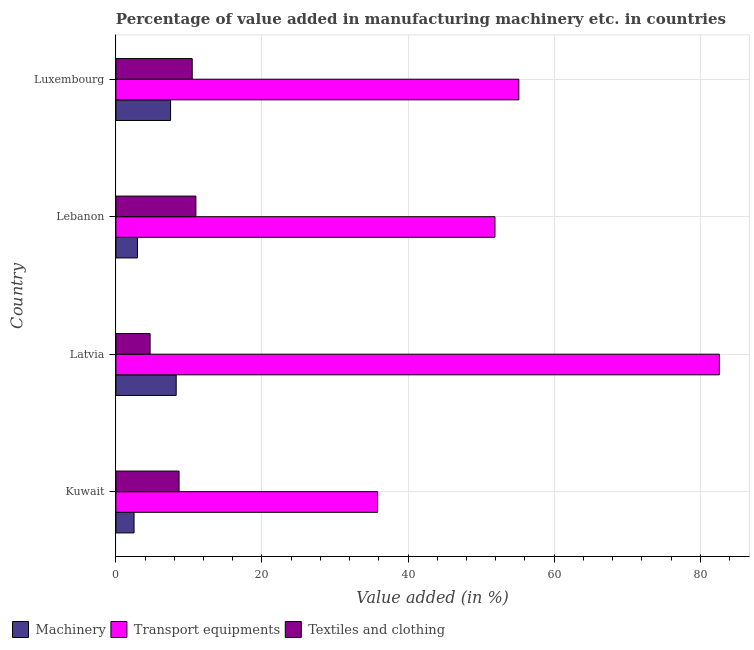How many different coloured bars are there?
Give a very brief answer. 3. How many groups of bars are there?
Give a very brief answer. 4. Are the number of bars per tick equal to the number of legend labels?
Your response must be concise. Yes. How many bars are there on the 3rd tick from the top?
Your answer should be very brief. 3. What is the label of the 2nd group of bars from the top?
Give a very brief answer. Lebanon. In how many cases, is the number of bars for a given country not equal to the number of legend labels?
Offer a very short reply. 0. What is the value added in manufacturing textile and clothing in Kuwait?
Keep it short and to the point. 8.65. Across all countries, what is the maximum value added in manufacturing textile and clothing?
Ensure brevity in your answer.  10.95. Across all countries, what is the minimum value added in manufacturing transport equipments?
Ensure brevity in your answer.  35.83. In which country was the value added in manufacturing transport equipments maximum?
Ensure brevity in your answer.  Latvia. In which country was the value added in manufacturing transport equipments minimum?
Provide a succinct answer. Kuwait. What is the total value added in manufacturing transport equipments in the graph?
Your answer should be very brief. 225.48. What is the difference between the value added in manufacturing textile and clothing in Latvia and that in Luxembourg?
Ensure brevity in your answer.  -5.77. What is the difference between the value added in manufacturing machinery in Luxembourg and the value added in manufacturing transport equipments in Lebanon?
Your answer should be compact. -44.41. What is the average value added in manufacturing transport equipments per country?
Keep it short and to the point. 56.37. What is the difference between the value added in manufacturing transport equipments and value added in manufacturing machinery in Lebanon?
Offer a very short reply. 48.94. What is the ratio of the value added in manufacturing transport equipments in Latvia to that in Luxembourg?
Ensure brevity in your answer.  1.5. Is the difference between the value added in manufacturing transport equipments in Kuwait and Latvia greater than the difference between the value added in manufacturing machinery in Kuwait and Latvia?
Your answer should be compact. No. What is the difference between the highest and the second highest value added in manufacturing transport equipments?
Your response must be concise. 27.45. What is the difference between the highest and the lowest value added in manufacturing textile and clothing?
Your answer should be very brief. 6.27. In how many countries, is the value added in manufacturing textile and clothing greater than the average value added in manufacturing textile and clothing taken over all countries?
Offer a very short reply. 2. Is the sum of the value added in manufacturing textile and clothing in Latvia and Luxembourg greater than the maximum value added in manufacturing transport equipments across all countries?
Your answer should be compact. No. What does the 1st bar from the top in Kuwait represents?
Your answer should be very brief. Textiles and clothing. What does the 1st bar from the bottom in Latvia represents?
Keep it short and to the point. Machinery. Is it the case that in every country, the sum of the value added in manufacturing machinery and value added in manufacturing transport equipments is greater than the value added in manufacturing textile and clothing?
Provide a short and direct response. Yes. What is the difference between two consecutive major ticks on the X-axis?
Offer a terse response. 20. Are the values on the major ticks of X-axis written in scientific E-notation?
Make the answer very short. No. Where does the legend appear in the graph?
Ensure brevity in your answer.  Bottom left. How many legend labels are there?
Offer a very short reply. 3. How are the legend labels stacked?
Your answer should be very brief. Horizontal. What is the title of the graph?
Give a very brief answer. Percentage of value added in manufacturing machinery etc. in countries. Does "Textiles and clothing" appear as one of the legend labels in the graph?
Your answer should be very brief. Yes. What is the label or title of the X-axis?
Your response must be concise. Value added (in %). What is the Value added (in %) in Machinery in Kuwait?
Provide a short and direct response. 2.49. What is the Value added (in %) of Transport equipments in Kuwait?
Your answer should be compact. 35.83. What is the Value added (in %) in Textiles and clothing in Kuwait?
Offer a very short reply. 8.65. What is the Value added (in %) of Machinery in Latvia?
Offer a terse response. 8.26. What is the Value added (in %) in Transport equipments in Latvia?
Provide a succinct answer. 82.6. What is the Value added (in %) of Textiles and clothing in Latvia?
Provide a succinct answer. 4.68. What is the Value added (in %) of Machinery in Lebanon?
Provide a succinct answer. 2.95. What is the Value added (in %) in Transport equipments in Lebanon?
Provide a short and direct response. 51.89. What is the Value added (in %) in Textiles and clothing in Lebanon?
Provide a succinct answer. 10.95. What is the Value added (in %) in Machinery in Luxembourg?
Give a very brief answer. 7.49. What is the Value added (in %) in Transport equipments in Luxembourg?
Offer a terse response. 55.16. What is the Value added (in %) of Textiles and clothing in Luxembourg?
Offer a very short reply. 10.45. Across all countries, what is the maximum Value added (in %) of Machinery?
Your response must be concise. 8.26. Across all countries, what is the maximum Value added (in %) of Transport equipments?
Keep it short and to the point. 82.6. Across all countries, what is the maximum Value added (in %) in Textiles and clothing?
Your response must be concise. 10.95. Across all countries, what is the minimum Value added (in %) in Machinery?
Ensure brevity in your answer.  2.49. Across all countries, what is the minimum Value added (in %) of Transport equipments?
Your response must be concise. 35.83. Across all countries, what is the minimum Value added (in %) in Textiles and clothing?
Make the answer very short. 4.68. What is the total Value added (in %) in Machinery in the graph?
Keep it short and to the point. 21.18. What is the total Value added (in %) in Transport equipments in the graph?
Offer a terse response. 225.48. What is the total Value added (in %) of Textiles and clothing in the graph?
Ensure brevity in your answer.  34.73. What is the difference between the Value added (in %) of Machinery in Kuwait and that in Latvia?
Give a very brief answer. -5.77. What is the difference between the Value added (in %) in Transport equipments in Kuwait and that in Latvia?
Provide a succinct answer. -46.78. What is the difference between the Value added (in %) in Textiles and clothing in Kuwait and that in Latvia?
Offer a terse response. 3.96. What is the difference between the Value added (in %) of Machinery in Kuwait and that in Lebanon?
Make the answer very short. -0.47. What is the difference between the Value added (in %) of Transport equipments in Kuwait and that in Lebanon?
Offer a very short reply. -16.07. What is the difference between the Value added (in %) of Textiles and clothing in Kuwait and that in Lebanon?
Your response must be concise. -2.3. What is the difference between the Value added (in %) of Machinery in Kuwait and that in Luxembourg?
Ensure brevity in your answer.  -5. What is the difference between the Value added (in %) of Transport equipments in Kuwait and that in Luxembourg?
Keep it short and to the point. -19.33. What is the difference between the Value added (in %) of Textiles and clothing in Kuwait and that in Luxembourg?
Offer a very short reply. -1.8. What is the difference between the Value added (in %) in Machinery in Latvia and that in Lebanon?
Give a very brief answer. 5.3. What is the difference between the Value added (in %) of Transport equipments in Latvia and that in Lebanon?
Provide a short and direct response. 30.71. What is the difference between the Value added (in %) of Textiles and clothing in Latvia and that in Lebanon?
Provide a succinct answer. -6.27. What is the difference between the Value added (in %) of Machinery in Latvia and that in Luxembourg?
Your response must be concise. 0.77. What is the difference between the Value added (in %) of Transport equipments in Latvia and that in Luxembourg?
Your answer should be compact. 27.45. What is the difference between the Value added (in %) in Textiles and clothing in Latvia and that in Luxembourg?
Offer a very short reply. -5.77. What is the difference between the Value added (in %) in Machinery in Lebanon and that in Luxembourg?
Make the answer very short. -4.53. What is the difference between the Value added (in %) in Transport equipments in Lebanon and that in Luxembourg?
Make the answer very short. -3.27. What is the difference between the Value added (in %) in Textiles and clothing in Lebanon and that in Luxembourg?
Provide a short and direct response. 0.5. What is the difference between the Value added (in %) in Machinery in Kuwait and the Value added (in %) in Transport equipments in Latvia?
Provide a succinct answer. -80.12. What is the difference between the Value added (in %) in Machinery in Kuwait and the Value added (in %) in Textiles and clothing in Latvia?
Provide a short and direct response. -2.2. What is the difference between the Value added (in %) of Transport equipments in Kuwait and the Value added (in %) of Textiles and clothing in Latvia?
Keep it short and to the point. 31.14. What is the difference between the Value added (in %) in Machinery in Kuwait and the Value added (in %) in Transport equipments in Lebanon?
Keep it short and to the point. -49.41. What is the difference between the Value added (in %) of Machinery in Kuwait and the Value added (in %) of Textiles and clothing in Lebanon?
Your answer should be compact. -8.46. What is the difference between the Value added (in %) of Transport equipments in Kuwait and the Value added (in %) of Textiles and clothing in Lebanon?
Give a very brief answer. 24.88. What is the difference between the Value added (in %) of Machinery in Kuwait and the Value added (in %) of Transport equipments in Luxembourg?
Make the answer very short. -52.67. What is the difference between the Value added (in %) in Machinery in Kuwait and the Value added (in %) in Textiles and clothing in Luxembourg?
Offer a terse response. -7.96. What is the difference between the Value added (in %) in Transport equipments in Kuwait and the Value added (in %) in Textiles and clothing in Luxembourg?
Make the answer very short. 25.38. What is the difference between the Value added (in %) in Machinery in Latvia and the Value added (in %) in Transport equipments in Lebanon?
Keep it short and to the point. -43.64. What is the difference between the Value added (in %) in Machinery in Latvia and the Value added (in %) in Textiles and clothing in Lebanon?
Offer a very short reply. -2.69. What is the difference between the Value added (in %) in Transport equipments in Latvia and the Value added (in %) in Textiles and clothing in Lebanon?
Offer a very short reply. 71.65. What is the difference between the Value added (in %) in Machinery in Latvia and the Value added (in %) in Transport equipments in Luxembourg?
Give a very brief answer. -46.9. What is the difference between the Value added (in %) of Machinery in Latvia and the Value added (in %) of Textiles and clothing in Luxembourg?
Give a very brief answer. -2.19. What is the difference between the Value added (in %) in Transport equipments in Latvia and the Value added (in %) in Textiles and clothing in Luxembourg?
Your response must be concise. 72.15. What is the difference between the Value added (in %) in Machinery in Lebanon and the Value added (in %) in Transport equipments in Luxembourg?
Provide a short and direct response. -52.2. What is the difference between the Value added (in %) in Machinery in Lebanon and the Value added (in %) in Textiles and clothing in Luxembourg?
Your answer should be compact. -7.5. What is the difference between the Value added (in %) of Transport equipments in Lebanon and the Value added (in %) of Textiles and clothing in Luxembourg?
Give a very brief answer. 41.44. What is the average Value added (in %) of Machinery per country?
Your answer should be compact. 5.3. What is the average Value added (in %) in Transport equipments per country?
Provide a short and direct response. 56.37. What is the average Value added (in %) in Textiles and clothing per country?
Your response must be concise. 8.68. What is the difference between the Value added (in %) of Machinery and Value added (in %) of Transport equipments in Kuwait?
Ensure brevity in your answer.  -33.34. What is the difference between the Value added (in %) in Machinery and Value added (in %) in Textiles and clothing in Kuwait?
Provide a succinct answer. -6.16. What is the difference between the Value added (in %) of Transport equipments and Value added (in %) of Textiles and clothing in Kuwait?
Provide a short and direct response. 27.18. What is the difference between the Value added (in %) in Machinery and Value added (in %) in Transport equipments in Latvia?
Give a very brief answer. -74.35. What is the difference between the Value added (in %) of Machinery and Value added (in %) of Textiles and clothing in Latvia?
Your response must be concise. 3.57. What is the difference between the Value added (in %) of Transport equipments and Value added (in %) of Textiles and clothing in Latvia?
Provide a succinct answer. 77.92. What is the difference between the Value added (in %) of Machinery and Value added (in %) of Transport equipments in Lebanon?
Make the answer very short. -48.94. What is the difference between the Value added (in %) in Machinery and Value added (in %) in Textiles and clothing in Lebanon?
Offer a terse response. -8. What is the difference between the Value added (in %) of Transport equipments and Value added (in %) of Textiles and clothing in Lebanon?
Ensure brevity in your answer.  40.94. What is the difference between the Value added (in %) in Machinery and Value added (in %) in Transport equipments in Luxembourg?
Provide a short and direct response. -47.67. What is the difference between the Value added (in %) of Machinery and Value added (in %) of Textiles and clothing in Luxembourg?
Provide a succinct answer. -2.96. What is the difference between the Value added (in %) in Transport equipments and Value added (in %) in Textiles and clothing in Luxembourg?
Give a very brief answer. 44.71. What is the ratio of the Value added (in %) in Machinery in Kuwait to that in Latvia?
Offer a terse response. 0.3. What is the ratio of the Value added (in %) of Transport equipments in Kuwait to that in Latvia?
Provide a succinct answer. 0.43. What is the ratio of the Value added (in %) in Textiles and clothing in Kuwait to that in Latvia?
Your answer should be very brief. 1.85. What is the ratio of the Value added (in %) of Machinery in Kuwait to that in Lebanon?
Your answer should be very brief. 0.84. What is the ratio of the Value added (in %) of Transport equipments in Kuwait to that in Lebanon?
Offer a terse response. 0.69. What is the ratio of the Value added (in %) of Textiles and clothing in Kuwait to that in Lebanon?
Ensure brevity in your answer.  0.79. What is the ratio of the Value added (in %) in Machinery in Kuwait to that in Luxembourg?
Ensure brevity in your answer.  0.33. What is the ratio of the Value added (in %) in Transport equipments in Kuwait to that in Luxembourg?
Your response must be concise. 0.65. What is the ratio of the Value added (in %) of Textiles and clothing in Kuwait to that in Luxembourg?
Ensure brevity in your answer.  0.83. What is the ratio of the Value added (in %) in Machinery in Latvia to that in Lebanon?
Ensure brevity in your answer.  2.8. What is the ratio of the Value added (in %) in Transport equipments in Latvia to that in Lebanon?
Your answer should be compact. 1.59. What is the ratio of the Value added (in %) in Textiles and clothing in Latvia to that in Lebanon?
Your answer should be compact. 0.43. What is the ratio of the Value added (in %) in Machinery in Latvia to that in Luxembourg?
Give a very brief answer. 1.1. What is the ratio of the Value added (in %) in Transport equipments in Latvia to that in Luxembourg?
Provide a succinct answer. 1.5. What is the ratio of the Value added (in %) in Textiles and clothing in Latvia to that in Luxembourg?
Ensure brevity in your answer.  0.45. What is the ratio of the Value added (in %) of Machinery in Lebanon to that in Luxembourg?
Give a very brief answer. 0.39. What is the ratio of the Value added (in %) of Transport equipments in Lebanon to that in Luxembourg?
Provide a succinct answer. 0.94. What is the ratio of the Value added (in %) in Textiles and clothing in Lebanon to that in Luxembourg?
Your answer should be very brief. 1.05. What is the difference between the highest and the second highest Value added (in %) in Machinery?
Keep it short and to the point. 0.77. What is the difference between the highest and the second highest Value added (in %) of Transport equipments?
Provide a succinct answer. 27.45. What is the difference between the highest and the second highest Value added (in %) of Textiles and clothing?
Give a very brief answer. 0.5. What is the difference between the highest and the lowest Value added (in %) in Machinery?
Provide a succinct answer. 5.77. What is the difference between the highest and the lowest Value added (in %) of Transport equipments?
Provide a short and direct response. 46.78. What is the difference between the highest and the lowest Value added (in %) of Textiles and clothing?
Ensure brevity in your answer.  6.27. 